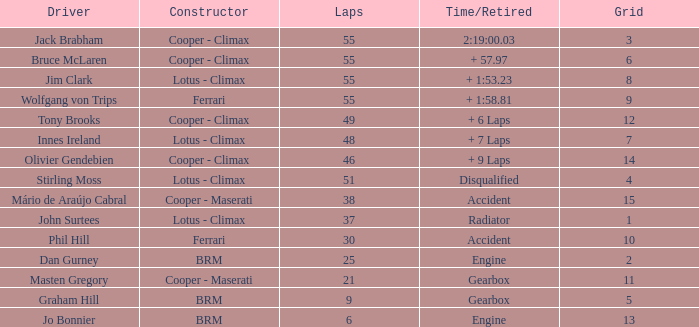Tell me the laps for 3 grids 55.0. 